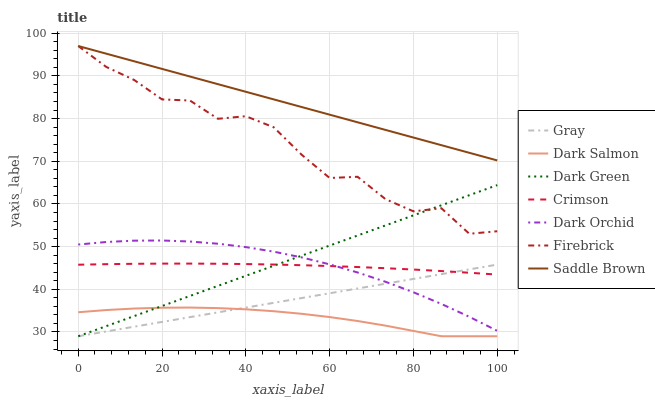Does Dark Salmon have the minimum area under the curve?
Answer yes or no. Yes. Does Saddle Brown have the maximum area under the curve?
Answer yes or no. Yes. Does Firebrick have the minimum area under the curve?
Answer yes or no. No. Does Firebrick have the maximum area under the curve?
Answer yes or no. No. Is Gray the smoothest?
Answer yes or no. Yes. Is Firebrick the roughest?
Answer yes or no. Yes. Is Dark Salmon the smoothest?
Answer yes or no. No. Is Dark Salmon the roughest?
Answer yes or no. No. Does Firebrick have the lowest value?
Answer yes or no. No. Does Saddle Brown have the highest value?
Answer yes or no. Yes. Does Dark Salmon have the highest value?
Answer yes or no. No. Is Crimson less than Saddle Brown?
Answer yes or no. Yes. Is Saddle Brown greater than Crimson?
Answer yes or no. Yes. Does Crimson intersect Saddle Brown?
Answer yes or no. No. 